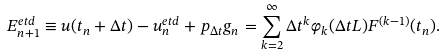Convert formula to latex. <formula><loc_0><loc_0><loc_500><loc_500>E _ { n + 1 } ^ { e t d } \equiv u ( t _ { n } + \Delta t ) - u _ { n } ^ { e t d } + p _ { \Delta t } g _ { n } = \sum _ { k = 2 } ^ { \infty } { \Delta t ^ { k } \varphi _ { k } ( \Delta t L ) F ^ { ( k - 1 ) } ( t _ { n } ) } .</formula> 